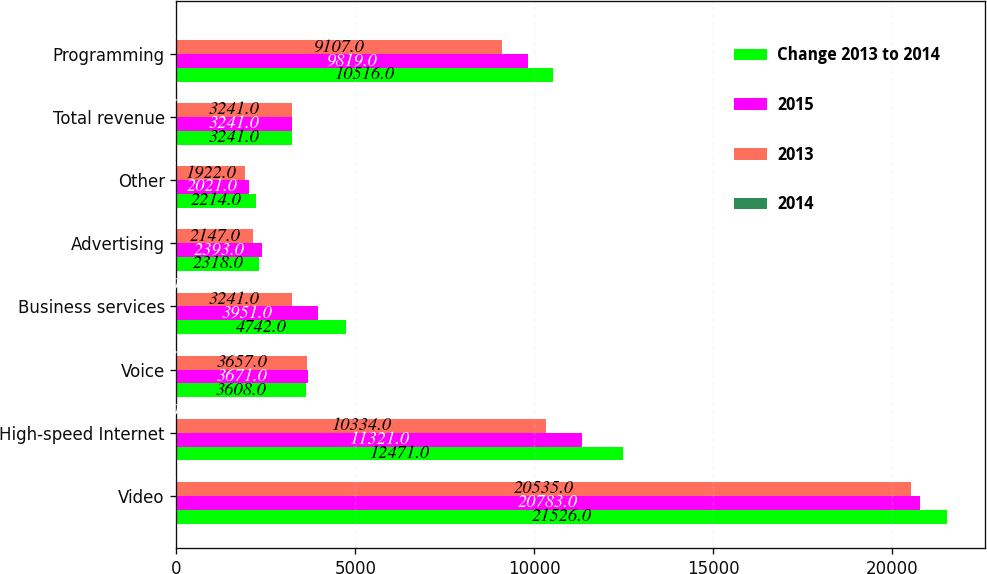Convert chart. <chart><loc_0><loc_0><loc_500><loc_500><stacked_bar_chart><ecel><fcel>Video<fcel>High-speed Internet<fcel>Voice<fcel>Business services<fcel>Advertising<fcel>Other<fcel>Total revenue<fcel>Programming<nl><fcel>Change 2013 to 2014<fcel>21526<fcel>12471<fcel>3608<fcel>4742<fcel>2318<fcel>2214<fcel>3241<fcel>10516<nl><fcel>2015<fcel>20783<fcel>11321<fcel>3671<fcel>3951<fcel>2393<fcel>2021<fcel>3241<fcel>9819<nl><fcel>2013<fcel>20535<fcel>10334<fcel>3657<fcel>3241<fcel>2147<fcel>1922<fcel>3241<fcel>9107<nl><fcel>2014<fcel>3.6<fcel>10.2<fcel>1.7<fcel>20<fcel>3.1<fcel>9.6<fcel>6.2<fcel>7.1<nl></chart> 